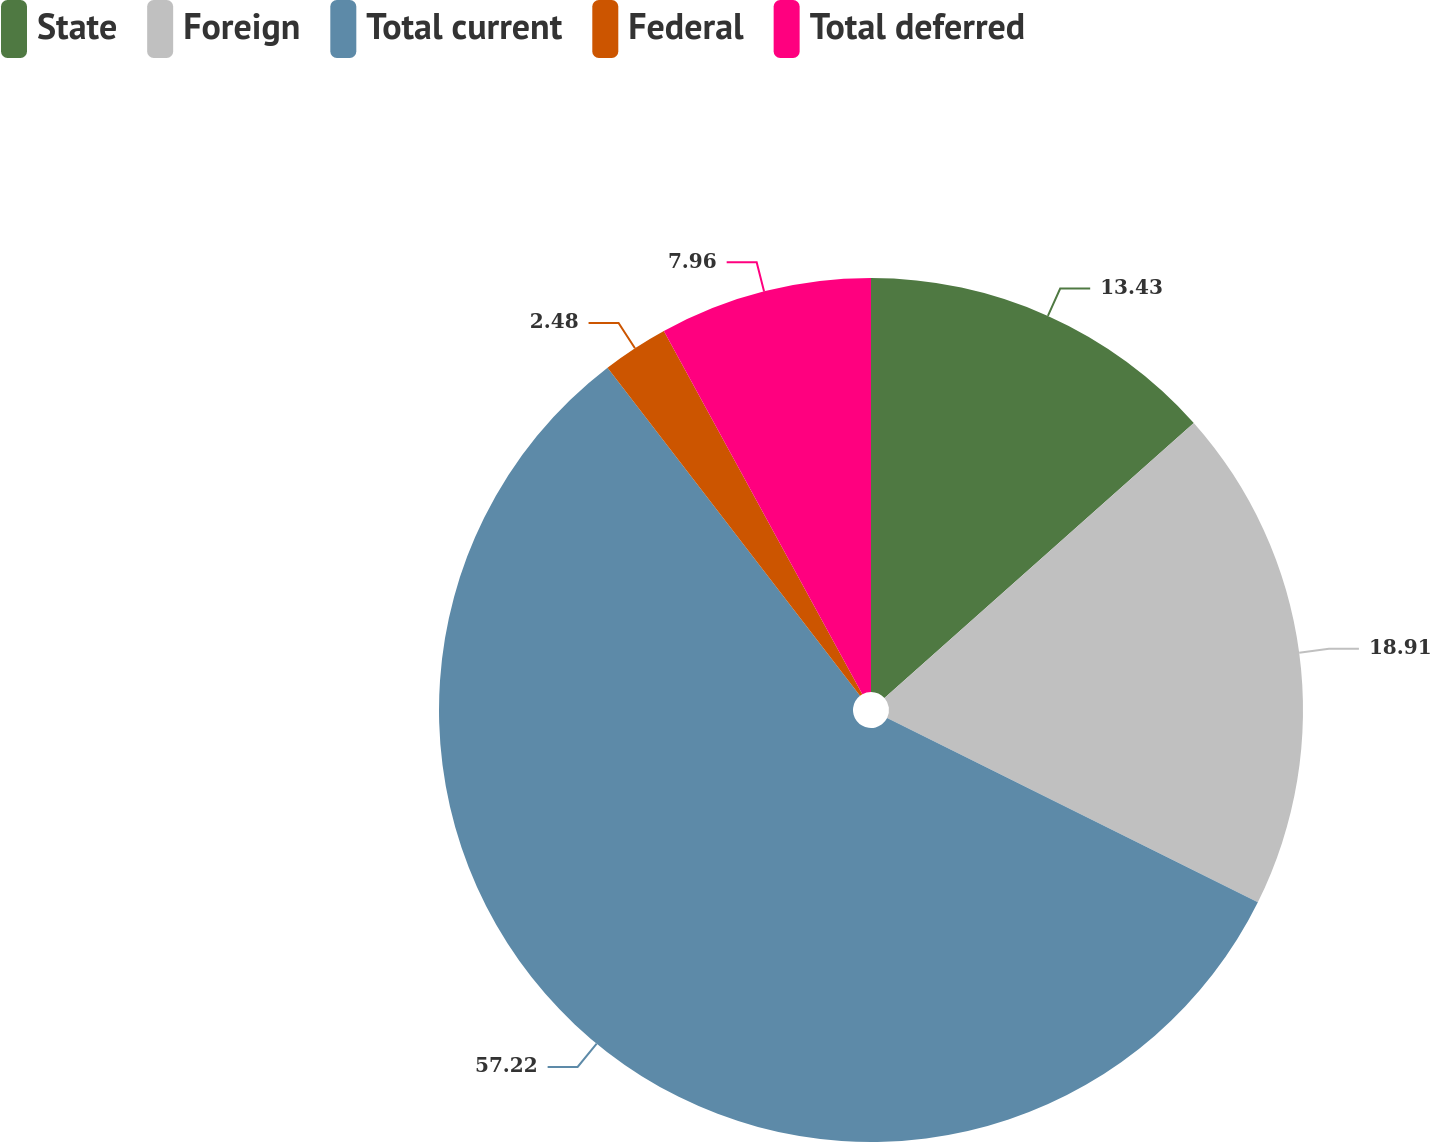<chart> <loc_0><loc_0><loc_500><loc_500><pie_chart><fcel>State<fcel>Foreign<fcel>Total current<fcel>Federal<fcel>Total deferred<nl><fcel>13.43%<fcel>18.91%<fcel>57.22%<fcel>2.48%<fcel>7.96%<nl></chart> 